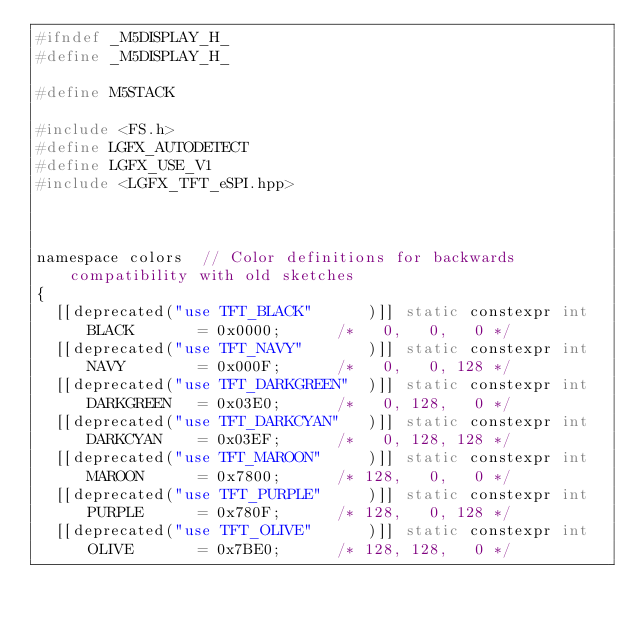<code> <loc_0><loc_0><loc_500><loc_500><_C_>#ifndef _M5DISPLAY_H_
#define _M5DISPLAY_H_

#define M5STACK

#include <FS.h>
#define LGFX_AUTODETECT
#define LGFX_USE_V1
#include <LGFX_TFT_eSPI.hpp>



namespace colors  // Color definitions for backwards compatibility with old sketches
{
  [[deprecated("use TFT_BLACK"      )]] static constexpr int BLACK       = 0x0000;      /*   0,   0,   0 */
  [[deprecated("use TFT_NAVY"       )]] static constexpr int NAVY        = 0x000F;      /*   0,   0, 128 */
  [[deprecated("use TFT_DARKGREEN"  )]] static constexpr int DARKGREEN   = 0x03E0;      /*   0, 128,   0 */
  [[deprecated("use TFT_DARKCYAN"   )]] static constexpr int DARKCYAN    = 0x03EF;      /*   0, 128, 128 */
  [[deprecated("use TFT_MAROON"     )]] static constexpr int MAROON      = 0x7800;      /* 128,   0,   0 */
  [[deprecated("use TFT_PURPLE"     )]] static constexpr int PURPLE      = 0x780F;      /* 128,   0, 128 */
  [[deprecated("use TFT_OLIVE"      )]] static constexpr int OLIVE       = 0x7BE0;      /* 128, 128,   0 */</code> 